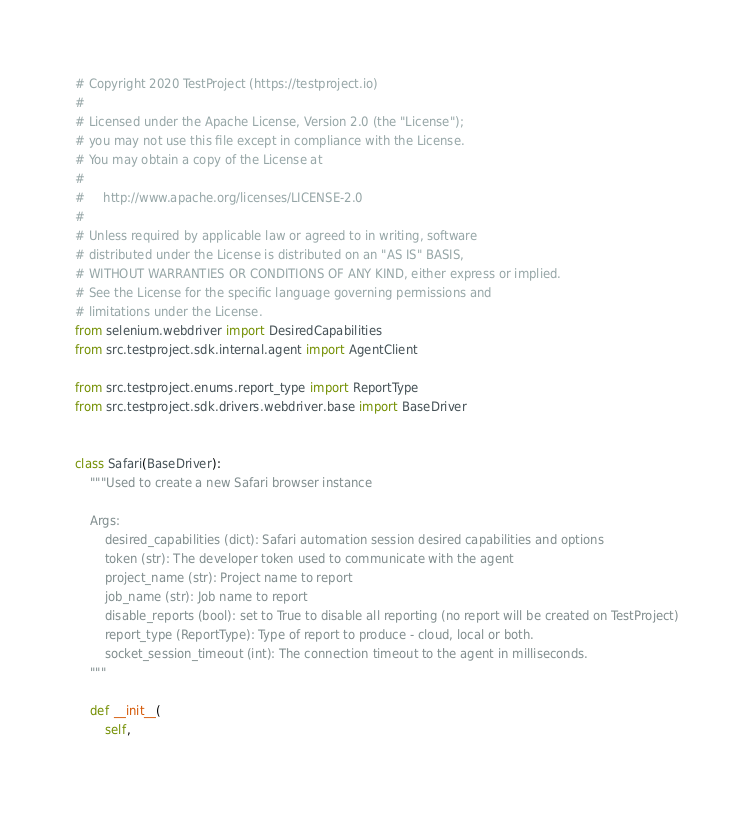<code> <loc_0><loc_0><loc_500><loc_500><_Python_># Copyright 2020 TestProject (https://testproject.io)
#
# Licensed under the Apache License, Version 2.0 (the "License");
# you may not use this file except in compliance with the License.
# You may obtain a copy of the License at
#
#     http://www.apache.org/licenses/LICENSE-2.0
#
# Unless required by applicable law or agreed to in writing, software
# distributed under the License is distributed on an "AS IS" BASIS,
# WITHOUT WARRANTIES OR CONDITIONS OF ANY KIND, either express or implied.
# See the License for the specific language governing permissions and
# limitations under the License.
from selenium.webdriver import DesiredCapabilities
from src.testproject.sdk.internal.agent import AgentClient

from src.testproject.enums.report_type import ReportType
from src.testproject.sdk.drivers.webdriver.base import BaseDriver


class Safari(BaseDriver):
    """Used to create a new Safari browser instance

    Args:
        desired_capabilities (dict): Safari automation session desired capabilities and options
        token (str): The developer token used to communicate with the agent
        project_name (str): Project name to report
        job_name (str): Job name to report
        disable_reports (bool): set to True to disable all reporting (no report will be created on TestProject)
        report_type (ReportType): Type of report to produce - cloud, local or both.
        socket_session_timeout (int): The connection timeout to the agent in milliseconds.
    """

    def __init__(
        self,</code> 